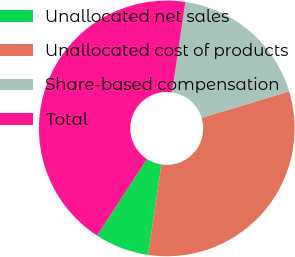Convert chart to OTSL. <chart><loc_0><loc_0><loc_500><loc_500><pie_chart><fcel>Unallocated net sales<fcel>Unallocated cost of products<fcel>Share-based compensation<fcel>Total<nl><fcel>6.83%<fcel>32.01%<fcel>17.99%<fcel>43.17%<nl></chart> 